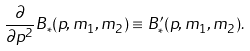Convert formula to latex. <formula><loc_0><loc_0><loc_500><loc_500>\frac { \partial } { \partial p ^ { 2 } } B _ { * } ( p , m _ { 1 } , m _ { 2 } ) \equiv B ^ { \prime } _ { * } ( p , m _ { 1 } , m _ { 2 } ) .</formula> 